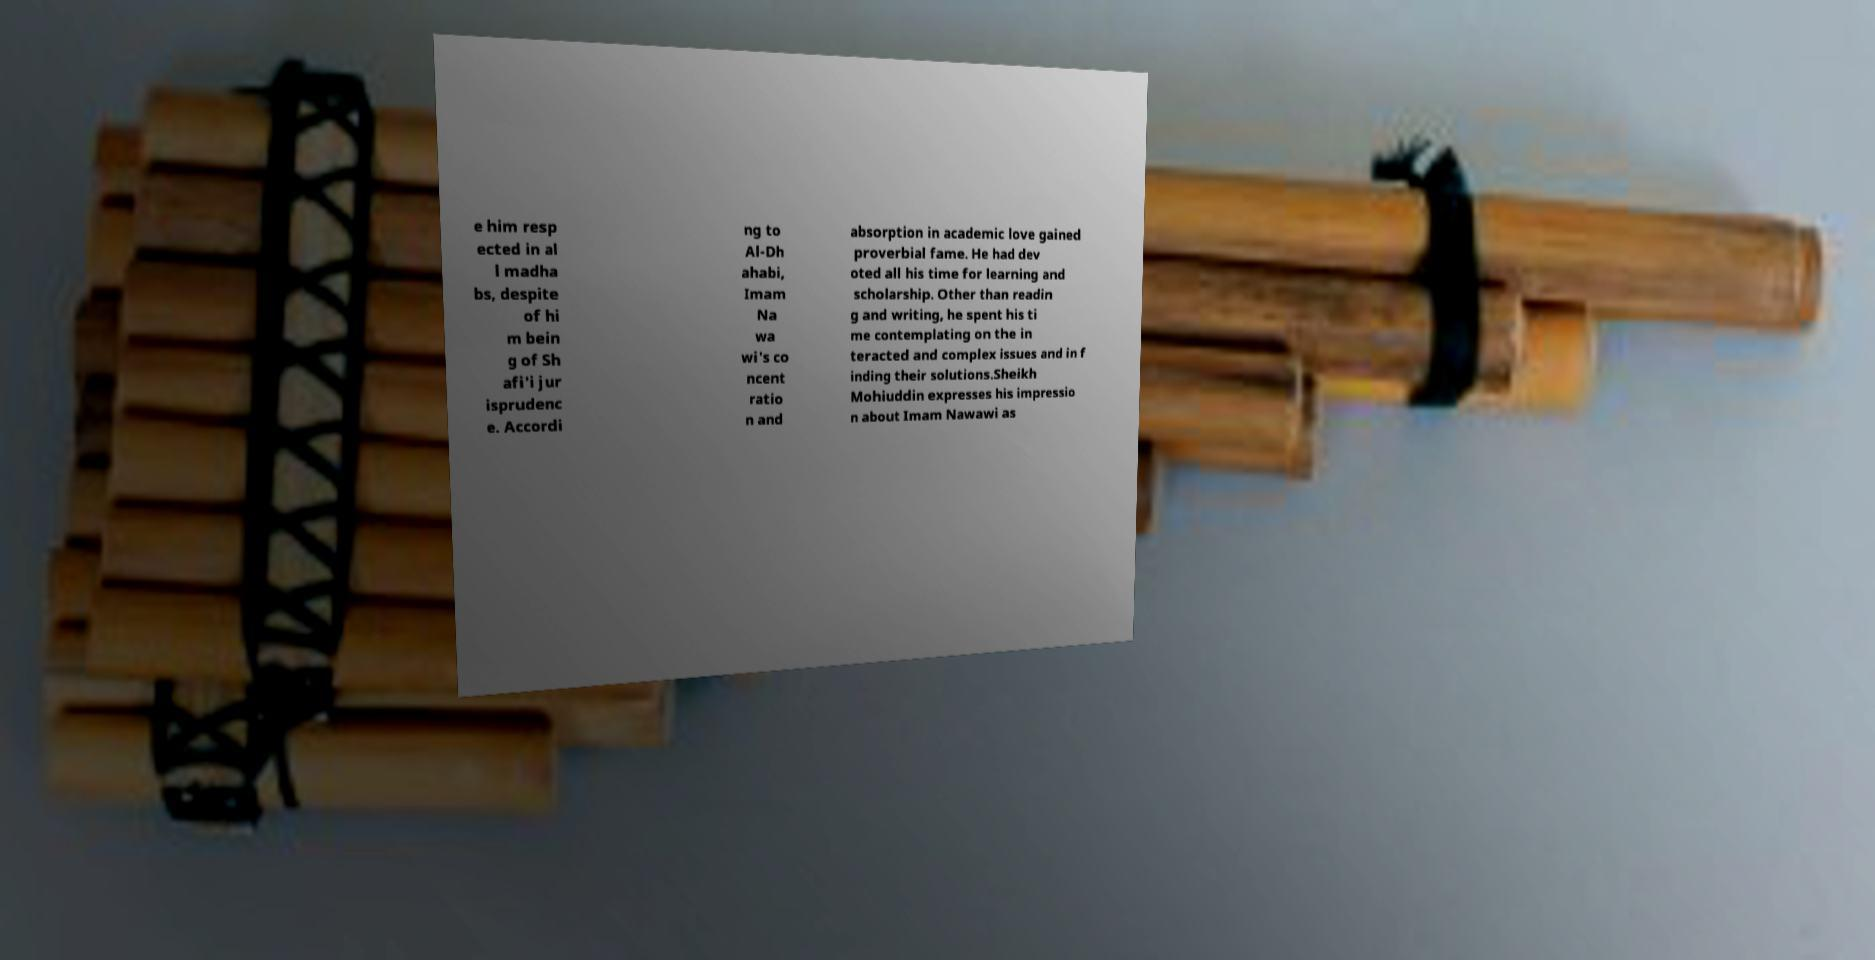For documentation purposes, I need the text within this image transcribed. Could you provide that? e him resp ected in al l madha bs, despite of hi m bein g of Sh afi'i jur isprudenc e. Accordi ng to Al-Dh ahabi, Imam Na wa wi's co ncent ratio n and absorption in academic love gained proverbial fame. He had dev oted all his time for learning and scholarship. Other than readin g and writing, he spent his ti me contemplating on the in teracted and complex issues and in f inding their solutions.Sheikh Mohiuddin expresses his impressio n about Imam Nawawi as 